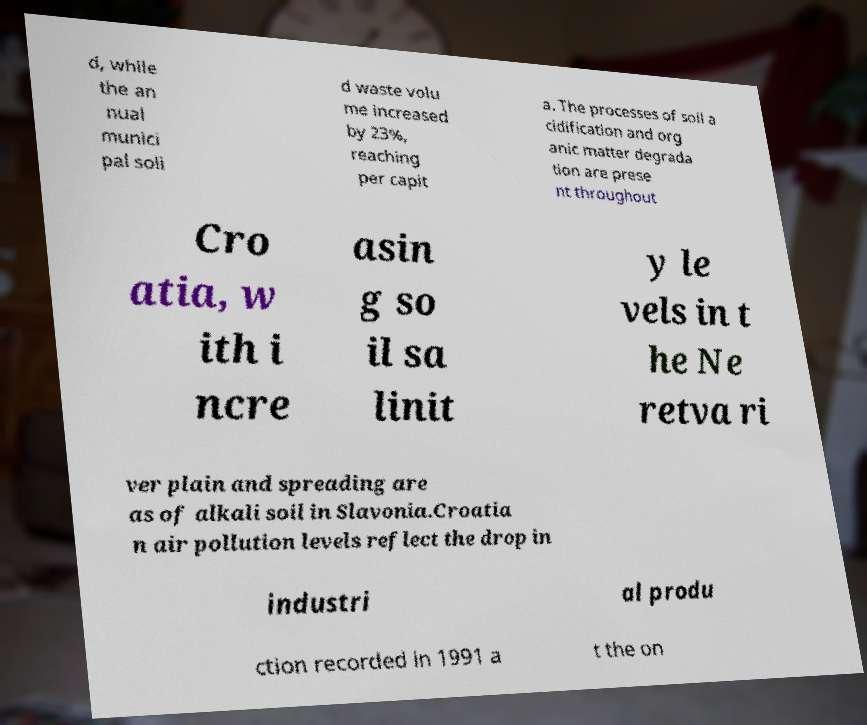Please identify and transcribe the text found in this image. d, while the an nual munici pal soli d waste volu me increased by 23%, reaching per capit a. The processes of soil a cidification and org anic matter degrada tion are prese nt throughout Cro atia, w ith i ncre asin g so il sa linit y le vels in t he Ne retva ri ver plain and spreading are as of alkali soil in Slavonia.Croatia n air pollution levels reflect the drop in industri al produ ction recorded in 1991 a t the on 